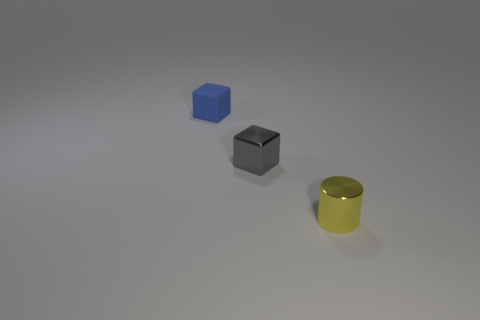There is a gray metallic thing that is the same size as the blue matte cube; what is its shape?
Keep it short and to the point. Cube. Is there anything else that is the same color as the shiny cube?
Give a very brief answer. No. What is the material of the other object that is the same shape as the tiny matte object?
Your answer should be very brief. Metal. What number of other things are there of the same size as the gray block?
Give a very brief answer. 2. There is a tiny thing that is in front of the small gray block; does it have the same shape as the blue object?
Offer a very short reply. No. What number of other things are the same shape as the small yellow shiny thing?
Make the answer very short. 0. The metallic object in front of the small gray object has what shape?
Make the answer very short. Cylinder. Are there any gray cylinders made of the same material as the yellow cylinder?
Ensure brevity in your answer.  No. Do the small shiny thing that is behind the tiny yellow metal object and the shiny cylinder have the same color?
Make the answer very short. No. How big is the blue object?
Make the answer very short. Small. 